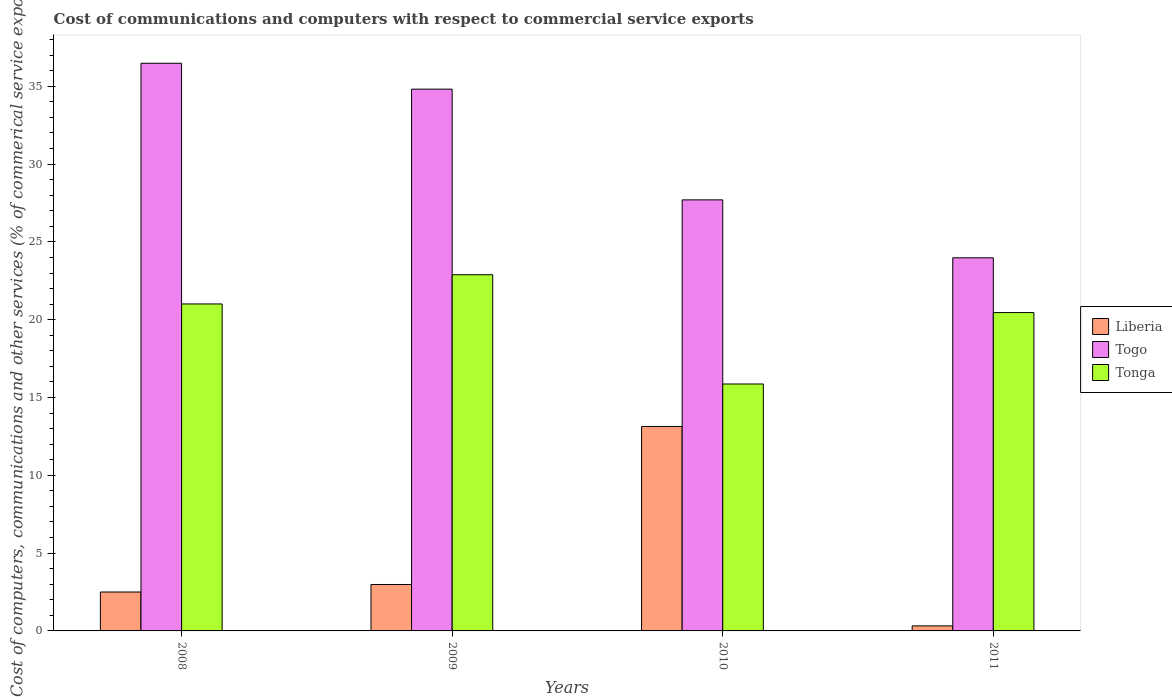How many groups of bars are there?
Your answer should be compact. 4. Are the number of bars per tick equal to the number of legend labels?
Offer a very short reply. Yes. How many bars are there on the 1st tick from the right?
Provide a succinct answer. 3. What is the label of the 2nd group of bars from the left?
Give a very brief answer. 2009. In how many cases, is the number of bars for a given year not equal to the number of legend labels?
Provide a succinct answer. 0. What is the cost of communications and computers in Liberia in 2011?
Your response must be concise. 0.32. Across all years, what is the maximum cost of communications and computers in Togo?
Offer a terse response. 36.48. Across all years, what is the minimum cost of communications and computers in Tonga?
Ensure brevity in your answer.  15.87. In which year was the cost of communications and computers in Liberia minimum?
Keep it short and to the point. 2011. What is the total cost of communications and computers in Togo in the graph?
Keep it short and to the point. 122.98. What is the difference between the cost of communications and computers in Tonga in 2008 and that in 2011?
Provide a succinct answer. 0.56. What is the difference between the cost of communications and computers in Togo in 2011 and the cost of communications and computers in Tonga in 2009?
Provide a succinct answer. 1.09. What is the average cost of communications and computers in Tonga per year?
Keep it short and to the point. 20.06. In the year 2009, what is the difference between the cost of communications and computers in Tonga and cost of communications and computers in Togo?
Offer a terse response. -11.93. What is the ratio of the cost of communications and computers in Togo in 2009 to that in 2011?
Make the answer very short. 1.45. Is the cost of communications and computers in Liberia in 2009 less than that in 2011?
Make the answer very short. No. What is the difference between the highest and the second highest cost of communications and computers in Tonga?
Offer a very short reply. 1.88. What is the difference between the highest and the lowest cost of communications and computers in Togo?
Provide a succinct answer. 12.5. Is the sum of the cost of communications and computers in Liberia in 2008 and 2010 greater than the maximum cost of communications and computers in Togo across all years?
Your answer should be compact. No. What does the 3rd bar from the left in 2008 represents?
Make the answer very short. Tonga. What does the 1st bar from the right in 2011 represents?
Provide a short and direct response. Tonga. Is it the case that in every year, the sum of the cost of communications and computers in Liberia and cost of communications and computers in Togo is greater than the cost of communications and computers in Tonga?
Give a very brief answer. Yes. Are all the bars in the graph horizontal?
Make the answer very short. No. How many years are there in the graph?
Your answer should be very brief. 4. Where does the legend appear in the graph?
Make the answer very short. Center right. What is the title of the graph?
Make the answer very short. Cost of communications and computers with respect to commercial service exports. Does "Uzbekistan" appear as one of the legend labels in the graph?
Your answer should be very brief. No. What is the label or title of the Y-axis?
Provide a short and direct response. Cost of computers, communications and other services (% of commerical service exports). What is the Cost of computers, communications and other services (% of commerical service exports) in Liberia in 2008?
Your response must be concise. 2.5. What is the Cost of computers, communications and other services (% of commerical service exports) of Togo in 2008?
Ensure brevity in your answer.  36.48. What is the Cost of computers, communications and other services (% of commerical service exports) of Tonga in 2008?
Give a very brief answer. 21.01. What is the Cost of computers, communications and other services (% of commerical service exports) of Liberia in 2009?
Provide a short and direct response. 2.98. What is the Cost of computers, communications and other services (% of commerical service exports) of Togo in 2009?
Give a very brief answer. 34.82. What is the Cost of computers, communications and other services (% of commerical service exports) in Tonga in 2009?
Make the answer very short. 22.89. What is the Cost of computers, communications and other services (% of commerical service exports) of Liberia in 2010?
Your answer should be very brief. 13.14. What is the Cost of computers, communications and other services (% of commerical service exports) in Togo in 2010?
Your answer should be compact. 27.7. What is the Cost of computers, communications and other services (% of commerical service exports) in Tonga in 2010?
Your answer should be very brief. 15.87. What is the Cost of computers, communications and other services (% of commerical service exports) of Liberia in 2011?
Keep it short and to the point. 0.32. What is the Cost of computers, communications and other services (% of commerical service exports) in Togo in 2011?
Keep it short and to the point. 23.98. What is the Cost of computers, communications and other services (% of commerical service exports) of Tonga in 2011?
Give a very brief answer. 20.46. Across all years, what is the maximum Cost of computers, communications and other services (% of commerical service exports) in Liberia?
Ensure brevity in your answer.  13.14. Across all years, what is the maximum Cost of computers, communications and other services (% of commerical service exports) of Togo?
Keep it short and to the point. 36.48. Across all years, what is the maximum Cost of computers, communications and other services (% of commerical service exports) in Tonga?
Your answer should be very brief. 22.89. Across all years, what is the minimum Cost of computers, communications and other services (% of commerical service exports) in Liberia?
Keep it short and to the point. 0.32. Across all years, what is the minimum Cost of computers, communications and other services (% of commerical service exports) in Togo?
Offer a terse response. 23.98. Across all years, what is the minimum Cost of computers, communications and other services (% of commerical service exports) in Tonga?
Your answer should be compact. 15.87. What is the total Cost of computers, communications and other services (% of commerical service exports) in Liberia in the graph?
Make the answer very short. 18.95. What is the total Cost of computers, communications and other services (% of commerical service exports) in Togo in the graph?
Offer a terse response. 122.98. What is the total Cost of computers, communications and other services (% of commerical service exports) of Tonga in the graph?
Your answer should be compact. 80.23. What is the difference between the Cost of computers, communications and other services (% of commerical service exports) in Liberia in 2008 and that in 2009?
Provide a succinct answer. -0.48. What is the difference between the Cost of computers, communications and other services (% of commerical service exports) of Togo in 2008 and that in 2009?
Provide a succinct answer. 1.66. What is the difference between the Cost of computers, communications and other services (% of commerical service exports) of Tonga in 2008 and that in 2009?
Provide a succinct answer. -1.88. What is the difference between the Cost of computers, communications and other services (% of commerical service exports) in Liberia in 2008 and that in 2010?
Offer a terse response. -10.64. What is the difference between the Cost of computers, communications and other services (% of commerical service exports) in Togo in 2008 and that in 2010?
Provide a short and direct response. 8.78. What is the difference between the Cost of computers, communications and other services (% of commerical service exports) in Tonga in 2008 and that in 2010?
Your response must be concise. 5.14. What is the difference between the Cost of computers, communications and other services (% of commerical service exports) in Liberia in 2008 and that in 2011?
Keep it short and to the point. 2.18. What is the difference between the Cost of computers, communications and other services (% of commerical service exports) in Togo in 2008 and that in 2011?
Give a very brief answer. 12.5. What is the difference between the Cost of computers, communications and other services (% of commerical service exports) in Tonga in 2008 and that in 2011?
Give a very brief answer. 0.56. What is the difference between the Cost of computers, communications and other services (% of commerical service exports) of Liberia in 2009 and that in 2010?
Give a very brief answer. -10.15. What is the difference between the Cost of computers, communications and other services (% of commerical service exports) of Togo in 2009 and that in 2010?
Your response must be concise. 7.12. What is the difference between the Cost of computers, communications and other services (% of commerical service exports) of Tonga in 2009 and that in 2010?
Your answer should be compact. 7.02. What is the difference between the Cost of computers, communications and other services (% of commerical service exports) in Liberia in 2009 and that in 2011?
Your answer should be very brief. 2.66. What is the difference between the Cost of computers, communications and other services (% of commerical service exports) of Togo in 2009 and that in 2011?
Offer a very short reply. 10.84. What is the difference between the Cost of computers, communications and other services (% of commerical service exports) of Tonga in 2009 and that in 2011?
Your answer should be compact. 2.43. What is the difference between the Cost of computers, communications and other services (% of commerical service exports) of Liberia in 2010 and that in 2011?
Your response must be concise. 12.81. What is the difference between the Cost of computers, communications and other services (% of commerical service exports) in Togo in 2010 and that in 2011?
Provide a short and direct response. 3.72. What is the difference between the Cost of computers, communications and other services (% of commerical service exports) in Tonga in 2010 and that in 2011?
Make the answer very short. -4.59. What is the difference between the Cost of computers, communications and other services (% of commerical service exports) of Liberia in 2008 and the Cost of computers, communications and other services (% of commerical service exports) of Togo in 2009?
Offer a very short reply. -32.32. What is the difference between the Cost of computers, communications and other services (% of commerical service exports) in Liberia in 2008 and the Cost of computers, communications and other services (% of commerical service exports) in Tonga in 2009?
Offer a terse response. -20.39. What is the difference between the Cost of computers, communications and other services (% of commerical service exports) of Togo in 2008 and the Cost of computers, communications and other services (% of commerical service exports) of Tonga in 2009?
Your answer should be very brief. 13.59. What is the difference between the Cost of computers, communications and other services (% of commerical service exports) in Liberia in 2008 and the Cost of computers, communications and other services (% of commerical service exports) in Togo in 2010?
Your response must be concise. -25.2. What is the difference between the Cost of computers, communications and other services (% of commerical service exports) of Liberia in 2008 and the Cost of computers, communications and other services (% of commerical service exports) of Tonga in 2010?
Give a very brief answer. -13.37. What is the difference between the Cost of computers, communications and other services (% of commerical service exports) in Togo in 2008 and the Cost of computers, communications and other services (% of commerical service exports) in Tonga in 2010?
Make the answer very short. 20.61. What is the difference between the Cost of computers, communications and other services (% of commerical service exports) in Liberia in 2008 and the Cost of computers, communications and other services (% of commerical service exports) in Togo in 2011?
Ensure brevity in your answer.  -21.48. What is the difference between the Cost of computers, communications and other services (% of commerical service exports) of Liberia in 2008 and the Cost of computers, communications and other services (% of commerical service exports) of Tonga in 2011?
Offer a very short reply. -17.96. What is the difference between the Cost of computers, communications and other services (% of commerical service exports) of Togo in 2008 and the Cost of computers, communications and other services (% of commerical service exports) of Tonga in 2011?
Your answer should be very brief. 16.02. What is the difference between the Cost of computers, communications and other services (% of commerical service exports) of Liberia in 2009 and the Cost of computers, communications and other services (% of commerical service exports) of Togo in 2010?
Ensure brevity in your answer.  -24.72. What is the difference between the Cost of computers, communications and other services (% of commerical service exports) of Liberia in 2009 and the Cost of computers, communications and other services (% of commerical service exports) of Tonga in 2010?
Your answer should be compact. -12.88. What is the difference between the Cost of computers, communications and other services (% of commerical service exports) in Togo in 2009 and the Cost of computers, communications and other services (% of commerical service exports) in Tonga in 2010?
Provide a short and direct response. 18.95. What is the difference between the Cost of computers, communications and other services (% of commerical service exports) in Liberia in 2009 and the Cost of computers, communications and other services (% of commerical service exports) in Togo in 2011?
Offer a terse response. -20.99. What is the difference between the Cost of computers, communications and other services (% of commerical service exports) in Liberia in 2009 and the Cost of computers, communications and other services (% of commerical service exports) in Tonga in 2011?
Ensure brevity in your answer.  -17.47. What is the difference between the Cost of computers, communications and other services (% of commerical service exports) in Togo in 2009 and the Cost of computers, communications and other services (% of commerical service exports) in Tonga in 2011?
Provide a short and direct response. 14.36. What is the difference between the Cost of computers, communications and other services (% of commerical service exports) in Liberia in 2010 and the Cost of computers, communications and other services (% of commerical service exports) in Togo in 2011?
Your answer should be very brief. -10.84. What is the difference between the Cost of computers, communications and other services (% of commerical service exports) of Liberia in 2010 and the Cost of computers, communications and other services (% of commerical service exports) of Tonga in 2011?
Offer a very short reply. -7.32. What is the difference between the Cost of computers, communications and other services (% of commerical service exports) of Togo in 2010 and the Cost of computers, communications and other services (% of commerical service exports) of Tonga in 2011?
Your answer should be compact. 7.24. What is the average Cost of computers, communications and other services (% of commerical service exports) in Liberia per year?
Your answer should be very brief. 4.74. What is the average Cost of computers, communications and other services (% of commerical service exports) in Togo per year?
Your answer should be compact. 30.74. What is the average Cost of computers, communications and other services (% of commerical service exports) in Tonga per year?
Your answer should be very brief. 20.06. In the year 2008, what is the difference between the Cost of computers, communications and other services (% of commerical service exports) in Liberia and Cost of computers, communications and other services (% of commerical service exports) in Togo?
Your answer should be compact. -33.98. In the year 2008, what is the difference between the Cost of computers, communications and other services (% of commerical service exports) in Liberia and Cost of computers, communications and other services (% of commerical service exports) in Tonga?
Ensure brevity in your answer.  -18.51. In the year 2008, what is the difference between the Cost of computers, communications and other services (% of commerical service exports) in Togo and Cost of computers, communications and other services (% of commerical service exports) in Tonga?
Provide a succinct answer. 15.47. In the year 2009, what is the difference between the Cost of computers, communications and other services (% of commerical service exports) in Liberia and Cost of computers, communications and other services (% of commerical service exports) in Togo?
Ensure brevity in your answer.  -31.83. In the year 2009, what is the difference between the Cost of computers, communications and other services (% of commerical service exports) in Liberia and Cost of computers, communications and other services (% of commerical service exports) in Tonga?
Your answer should be compact. -19.91. In the year 2009, what is the difference between the Cost of computers, communications and other services (% of commerical service exports) in Togo and Cost of computers, communications and other services (% of commerical service exports) in Tonga?
Give a very brief answer. 11.93. In the year 2010, what is the difference between the Cost of computers, communications and other services (% of commerical service exports) of Liberia and Cost of computers, communications and other services (% of commerical service exports) of Togo?
Provide a succinct answer. -14.56. In the year 2010, what is the difference between the Cost of computers, communications and other services (% of commerical service exports) of Liberia and Cost of computers, communications and other services (% of commerical service exports) of Tonga?
Offer a very short reply. -2.73. In the year 2010, what is the difference between the Cost of computers, communications and other services (% of commerical service exports) in Togo and Cost of computers, communications and other services (% of commerical service exports) in Tonga?
Provide a short and direct response. 11.83. In the year 2011, what is the difference between the Cost of computers, communications and other services (% of commerical service exports) in Liberia and Cost of computers, communications and other services (% of commerical service exports) in Togo?
Offer a terse response. -23.65. In the year 2011, what is the difference between the Cost of computers, communications and other services (% of commerical service exports) of Liberia and Cost of computers, communications and other services (% of commerical service exports) of Tonga?
Your response must be concise. -20.13. In the year 2011, what is the difference between the Cost of computers, communications and other services (% of commerical service exports) in Togo and Cost of computers, communications and other services (% of commerical service exports) in Tonga?
Ensure brevity in your answer.  3.52. What is the ratio of the Cost of computers, communications and other services (% of commerical service exports) in Liberia in 2008 to that in 2009?
Keep it short and to the point. 0.84. What is the ratio of the Cost of computers, communications and other services (% of commerical service exports) in Togo in 2008 to that in 2009?
Your response must be concise. 1.05. What is the ratio of the Cost of computers, communications and other services (% of commerical service exports) of Tonga in 2008 to that in 2009?
Offer a very short reply. 0.92. What is the ratio of the Cost of computers, communications and other services (% of commerical service exports) of Liberia in 2008 to that in 2010?
Ensure brevity in your answer.  0.19. What is the ratio of the Cost of computers, communications and other services (% of commerical service exports) of Togo in 2008 to that in 2010?
Offer a terse response. 1.32. What is the ratio of the Cost of computers, communications and other services (% of commerical service exports) of Tonga in 2008 to that in 2010?
Keep it short and to the point. 1.32. What is the ratio of the Cost of computers, communications and other services (% of commerical service exports) in Liberia in 2008 to that in 2011?
Offer a very short reply. 7.74. What is the ratio of the Cost of computers, communications and other services (% of commerical service exports) of Togo in 2008 to that in 2011?
Your response must be concise. 1.52. What is the ratio of the Cost of computers, communications and other services (% of commerical service exports) of Tonga in 2008 to that in 2011?
Ensure brevity in your answer.  1.03. What is the ratio of the Cost of computers, communications and other services (% of commerical service exports) of Liberia in 2009 to that in 2010?
Offer a terse response. 0.23. What is the ratio of the Cost of computers, communications and other services (% of commerical service exports) of Togo in 2009 to that in 2010?
Your answer should be very brief. 1.26. What is the ratio of the Cost of computers, communications and other services (% of commerical service exports) in Tonga in 2009 to that in 2010?
Keep it short and to the point. 1.44. What is the ratio of the Cost of computers, communications and other services (% of commerical service exports) in Liberia in 2009 to that in 2011?
Provide a short and direct response. 9.23. What is the ratio of the Cost of computers, communications and other services (% of commerical service exports) in Togo in 2009 to that in 2011?
Your answer should be compact. 1.45. What is the ratio of the Cost of computers, communications and other services (% of commerical service exports) in Tonga in 2009 to that in 2011?
Provide a succinct answer. 1.12. What is the ratio of the Cost of computers, communications and other services (% of commerical service exports) of Liberia in 2010 to that in 2011?
Your response must be concise. 40.64. What is the ratio of the Cost of computers, communications and other services (% of commerical service exports) of Togo in 2010 to that in 2011?
Ensure brevity in your answer.  1.16. What is the ratio of the Cost of computers, communications and other services (% of commerical service exports) of Tonga in 2010 to that in 2011?
Ensure brevity in your answer.  0.78. What is the difference between the highest and the second highest Cost of computers, communications and other services (% of commerical service exports) of Liberia?
Your response must be concise. 10.15. What is the difference between the highest and the second highest Cost of computers, communications and other services (% of commerical service exports) in Togo?
Offer a terse response. 1.66. What is the difference between the highest and the second highest Cost of computers, communications and other services (% of commerical service exports) of Tonga?
Provide a short and direct response. 1.88. What is the difference between the highest and the lowest Cost of computers, communications and other services (% of commerical service exports) of Liberia?
Your answer should be compact. 12.81. What is the difference between the highest and the lowest Cost of computers, communications and other services (% of commerical service exports) in Togo?
Your answer should be compact. 12.5. What is the difference between the highest and the lowest Cost of computers, communications and other services (% of commerical service exports) of Tonga?
Your answer should be very brief. 7.02. 